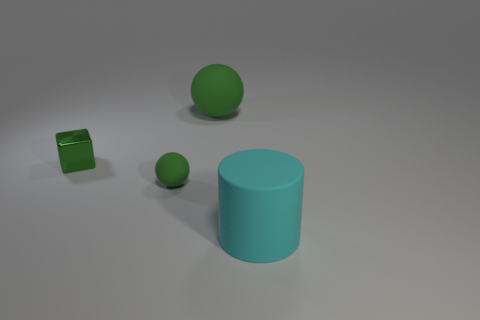What do you think is the significance of the color choices for the objects? From an artistic perspective, the color choices could represent a deliberate attempt to evoke a sense of harmony and simplicity. The cyan and green hues are adjacent on the color wheel, which typically suggests a pleasing visual experience. The use of similar colors but different shapes may also be a way to explore the interaction between form and color in a minimalistic setting. Can you draw any metaphorical meanings from the arrangement of these objects? Metaphorically, it could be interpreted that the objects represent individuals or elements in a society or system. The large cylinder might symbolize a central authority or common belief that stands firm, while the smaller sphere and cube could represent diverse individuals or groups. Their positions, not too close but yet orderly arranged, might suggest a sense of coexistence and structure within the space they inhabit. 